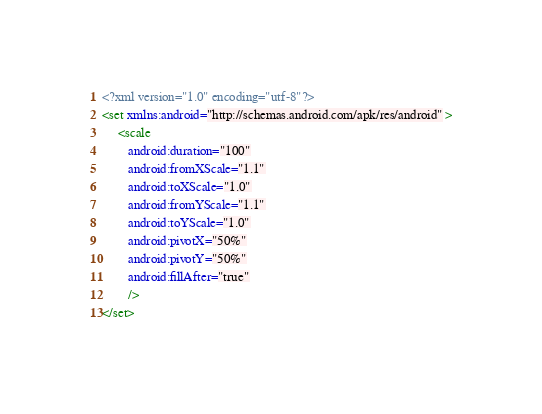Convert code to text. <code><loc_0><loc_0><loc_500><loc_500><_XML_><?xml version="1.0" encoding="utf-8"?>
<set xmlns:android="http://schemas.android.com/apk/res/android" >
     <scale
        android:duration="100"
        android:fromXScale="1.1"
        android:toXScale="1.0"
        android:fromYScale="1.1"
        android:toYScale="1.0" 
        android:pivotX="50%" 
        android:pivotY="50%" 
        android:fillAfter="true"
        /> 
</set></code> 